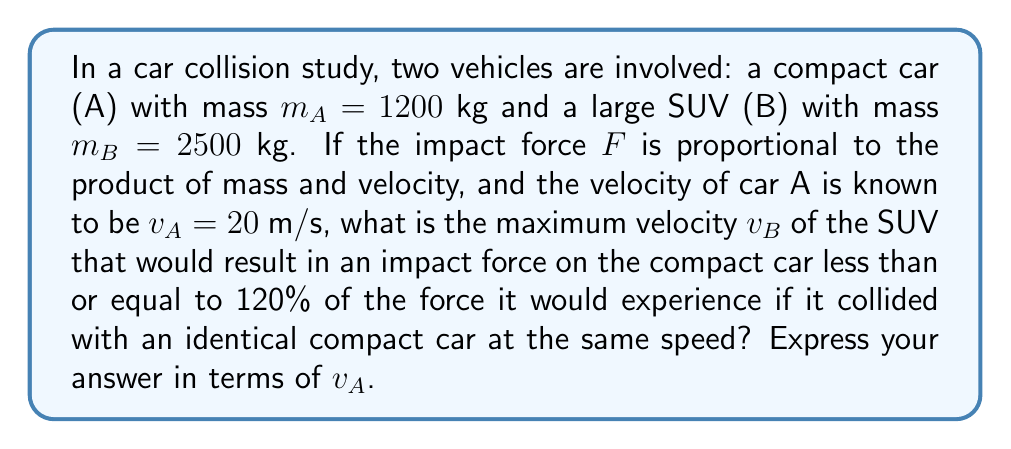Solve this math problem. Let's approach this step-by-step:

1) The impact force is proportional to the product of mass and velocity. For car A colliding with an identical car, we can express this as:
   $$F_A \propto m_A \cdot v_A$$

2) For car A colliding with the SUV (car B), the force would be:
   $$F_{AB} \propto m_B \cdot v_B$$

3) We want $F_{AB}$ to be less than or equal to 120% of $F_A$:
   $$m_B \cdot v_B \leq 1.2 \cdot m_A \cdot v_A$$

4) Substituting the known values:
   $$2500 \cdot v_B \leq 1.2 \cdot 1200 \cdot 20$$

5) Simplifying the right side:
   $$2500 \cdot v_B \leq 28800$$

6) Dividing both sides by 2500:
   $$v_B \leq \frac{28800}{2500} = 11.52$$

7) Expressing this in terms of $v_A$:
   $$v_B \leq \frac{11.52}{20} \cdot v_A = 0.576 \cdot v_A$$

Therefore, the maximum velocity of the SUV should be less than or equal to 0.576 times the velocity of car A.
Answer: $v_B \leq 0.576v_A$ 